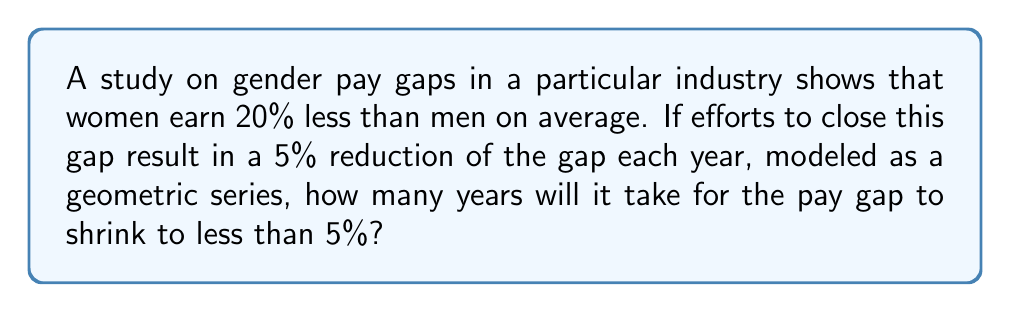Give your solution to this math problem. Let's approach this step-by-step:

1) The initial pay gap is 20%. We want to find when it becomes less than 5%.

2) Each year, the gap is reduced by 5% of its previous value. This means that each year, 95% of the gap remains.

3) We can model this as a geometric series with:
   - Initial term $a = 20$ (the initial 20% gap)
   - Common ratio $r = 0.95$ (95% of the gap remains each year)

4) The formula for the nth term of a geometric sequence is:
   $$a_n = a \cdot r^{n-1}$$

5) We want to find $n$ when $a_n < 5$:
   $$20 \cdot 0.95^{n-1} < 5$$

6) Dividing both sides by 20:
   $$0.95^{n-1} < 0.25$$

7) Taking the natural log of both sides:
   $$(n-1) \cdot \ln(0.95) < \ln(0.25)$$

8) Solving for $n$:
   $$n > 1 + \frac{\ln(0.25)}{\ln(0.95)} \approx 27.93$$

9) Since $n$ must be a whole number of years, we round up to 28.
Answer: 28 years 